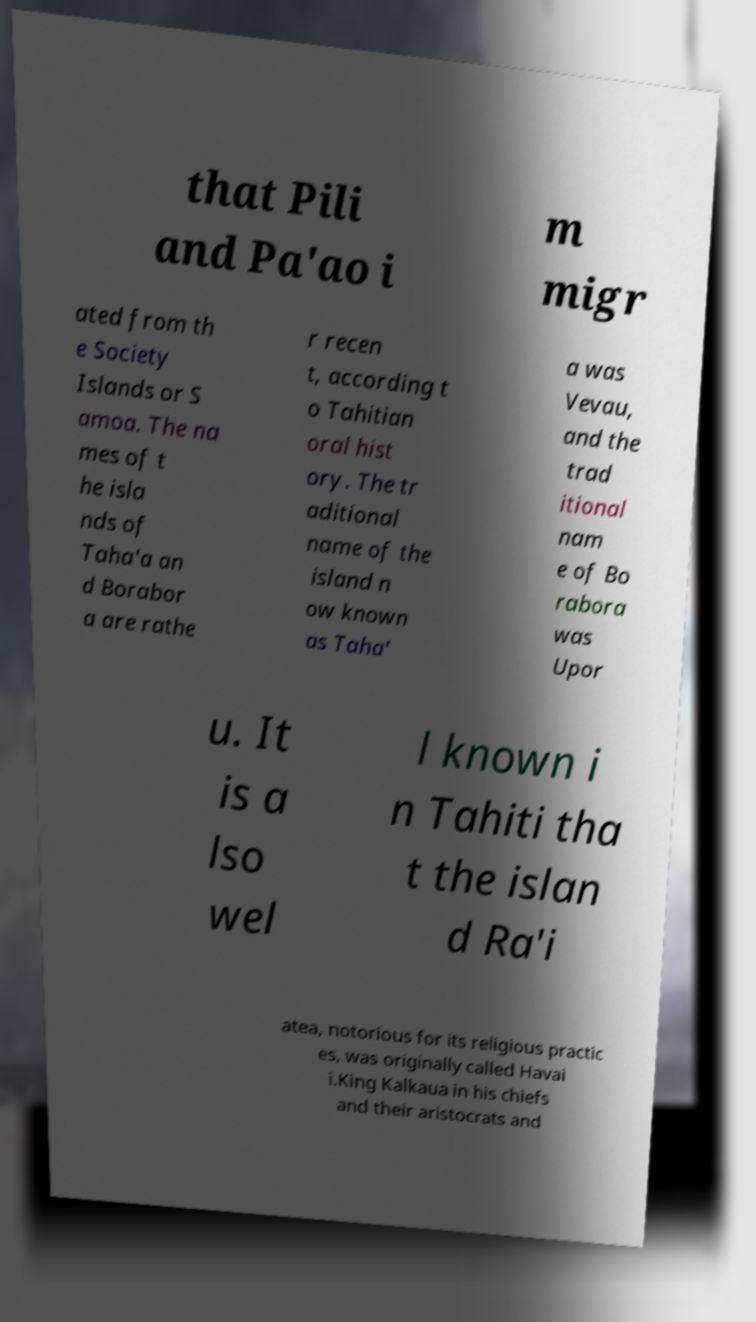What messages or text are displayed in this image? I need them in a readable, typed format. that Pili and Pa'ao i m migr ated from th e Society Islands or S amoa. The na mes of t he isla nds of Taha'a an d Borabor a are rathe r recen t, according t o Tahitian oral hist ory. The tr aditional name of the island n ow known as Taha' a was Vevau, and the trad itional nam e of Bo rabora was Upor u. It is a lso wel l known i n Tahiti tha t the islan d Ra'i atea, notorious for its religious practic es, was originally called Havai i.King Kalkaua in his chiefs and their aristocrats and 